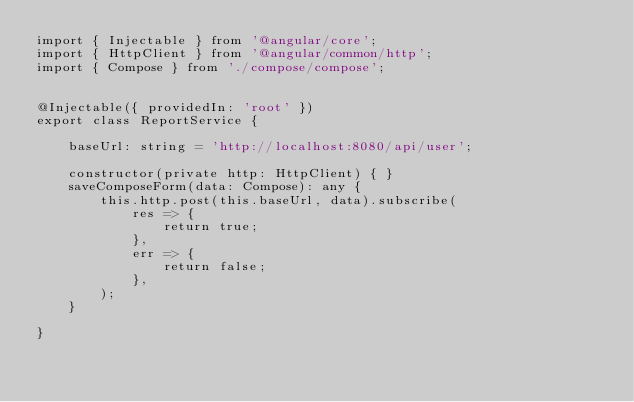Convert code to text. <code><loc_0><loc_0><loc_500><loc_500><_TypeScript_>import { Injectable } from '@angular/core';
import { HttpClient } from '@angular/common/http';
import { Compose } from './compose/compose';


@Injectable({ providedIn: 'root' })
export class ReportService {

    baseUrl: string = 'http://localhost:8080/api/user';

    constructor(private http: HttpClient) { }
    saveComposeForm(data: Compose): any {
        this.http.post(this.baseUrl, data).subscribe(
            res => {
                return true;
            },
            err => {
                return false;
            },
        );
    }

}
</code> 